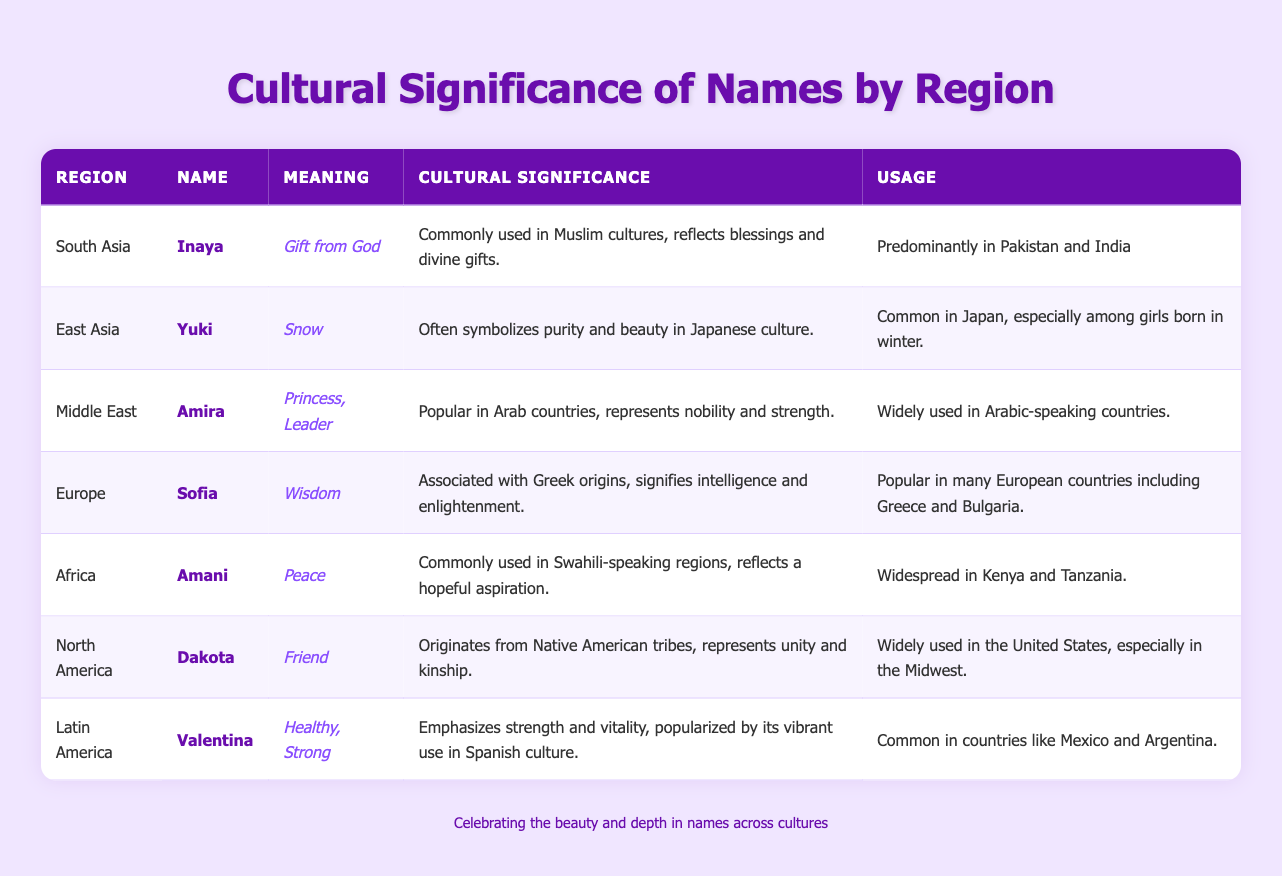What is the meaning of the name Inaya? The meaning of Inaya is provided in the table under the "Meaning" column for South Asia, which states "Gift from God."
Answer: Gift from God Which region uses the name Amani predominantly? The "Usage" column for the name Amani indicates that it is widespread in Kenya and Tanzania, which are located in Africa.
Answer: Africa Is the name Valentina associated with strength? The "Cultural Significance" column for Valentina mentions that it emphasizes strength and vitality, making this statement true.
Answer: Yes What cultural significance is associated with the name Amira? According to the "Cultural Significance" column for Amira in the Middle East, it is described as representing nobility and strength.
Answer: Nobility and strength How many names symbolize beauty or purity? From the names listed, Yuki symbolizes beauty and purity in East Asia, while Amani, although meaning peace, has connections to hopeful aspirations, therefore contributing to a sense of beauty in a broader context. However, the specific focus is primarily on Yuki.
Answer: 1 